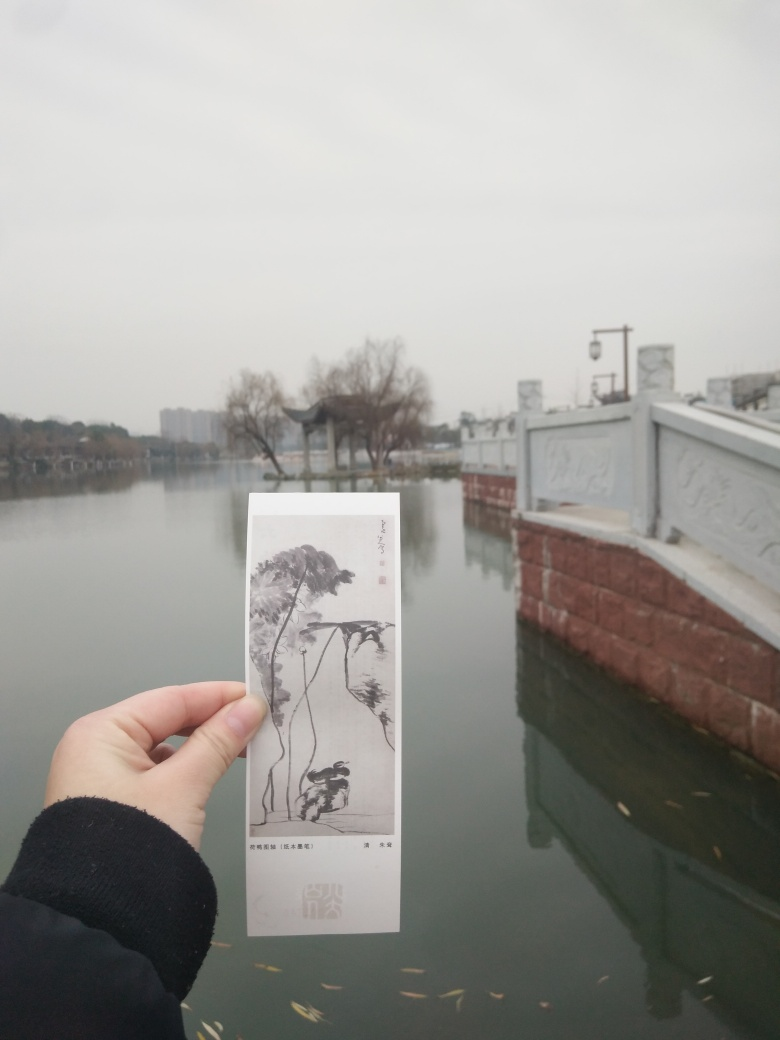Could you describe the weather conditions at the time this photo was taken? The overcast sky and the absence of sharp shadows suggest an overcast or possibly hazy day. The overall soft light with no strong contrasts implies that the photo was taken on a day with diffuse sunlight, often associated with cloudy or foggy weather conditions. 